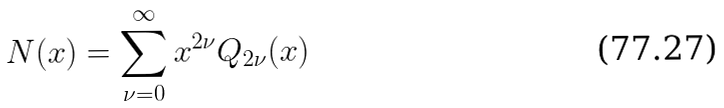Convert formula to latex. <formula><loc_0><loc_0><loc_500><loc_500>N ( x ) = \sum _ { \nu = 0 } ^ { \infty } x ^ { 2 \nu } Q _ { 2 \nu } ( x )</formula> 